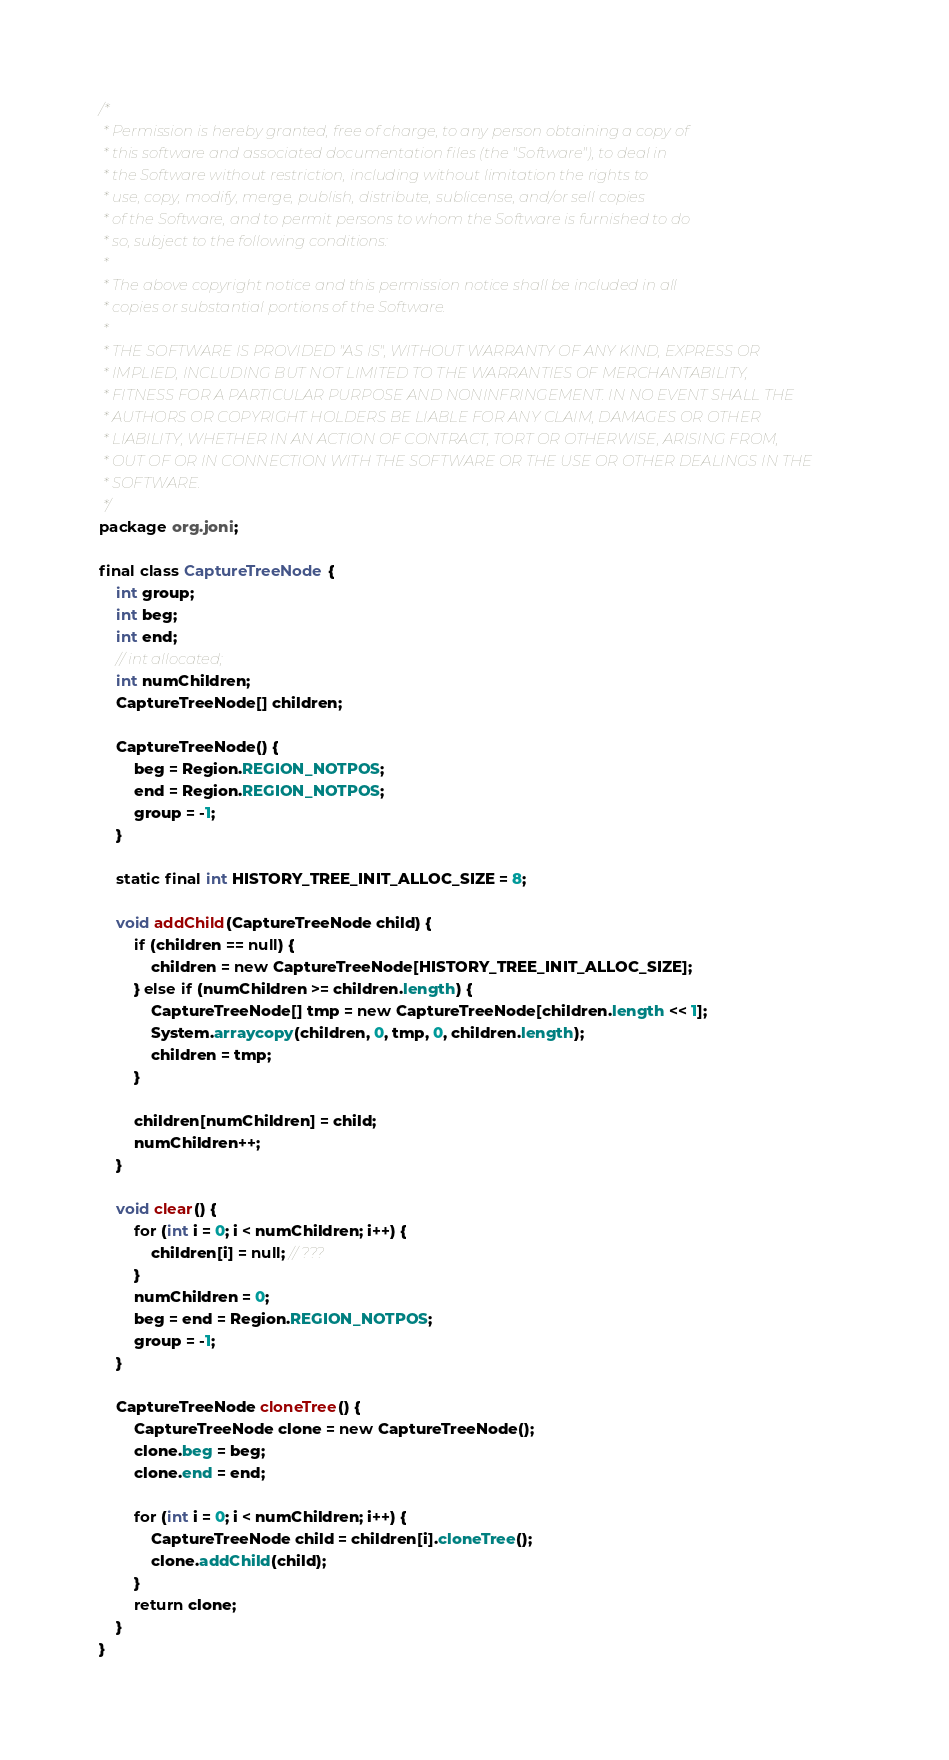Convert code to text. <code><loc_0><loc_0><loc_500><loc_500><_Java_>/*
 * Permission is hereby granted, free of charge, to any person obtaining a copy of
 * this software and associated documentation files (the "Software"), to deal in
 * the Software without restriction, including without limitation the rights to
 * use, copy, modify, merge, publish, distribute, sublicense, and/or sell copies
 * of the Software, and to permit persons to whom the Software is furnished to do
 * so, subject to the following conditions:
 *
 * The above copyright notice and this permission notice shall be included in all
 * copies or substantial portions of the Software.
 *
 * THE SOFTWARE IS PROVIDED "AS IS", WITHOUT WARRANTY OF ANY KIND, EXPRESS OR
 * IMPLIED, INCLUDING BUT NOT LIMITED TO THE WARRANTIES OF MERCHANTABILITY,
 * FITNESS FOR A PARTICULAR PURPOSE AND NONINFRINGEMENT. IN NO EVENT SHALL THE
 * AUTHORS OR COPYRIGHT HOLDERS BE LIABLE FOR ANY CLAIM, DAMAGES OR OTHER
 * LIABILITY, WHETHER IN AN ACTION OF CONTRACT, TORT OR OTHERWISE, ARISING FROM,
 * OUT OF OR IN CONNECTION WITH THE SOFTWARE OR THE USE OR OTHER DEALINGS IN THE
 * SOFTWARE.
 */
package org.joni;

final class CaptureTreeNode {
    int group;
    int beg;
    int end;
    // int allocated;
    int numChildren;
    CaptureTreeNode[] children;

    CaptureTreeNode() {
        beg = Region.REGION_NOTPOS;
        end = Region.REGION_NOTPOS;
        group = -1;
    }

    static final int HISTORY_TREE_INIT_ALLOC_SIZE = 8;

    void addChild(CaptureTreeNode child) {
        if (children == null) {
            children = new CaptureTreeNode[HISTORY_TREE_INIT_ALLOC_SIZE];
        } else if (numChildren >= children.length) {
            CaptureTreeNode[] tmp = new CaptureTreeNode[children.length << 1];
            System.arraycopy(children, 0, tmp, 0, children.length);
            children = tmp;
        }

        children[numChildren] = child;
        numChildren++;
    }

    void clear() {
        for (int i = 0; i < numChildren; i++) {
            children[i] = null; // ???
        }
        numChildren = 0;
        beg = end = Region.REGION_NOTPOS;
        group = -1;
    }

    CaptureTreeNode cloneTree() {
        CaptureTreeNode clone = new CaptureTreeNode();
        clone.beg = beg;
        clone.end = end;

        for (int i = 0; i < numChildren; i++) {
            CaptureTreeNode child = children[i].cloneTree();
            clone.addChild(child);
        }
        return clone;
    }
}
</code> 